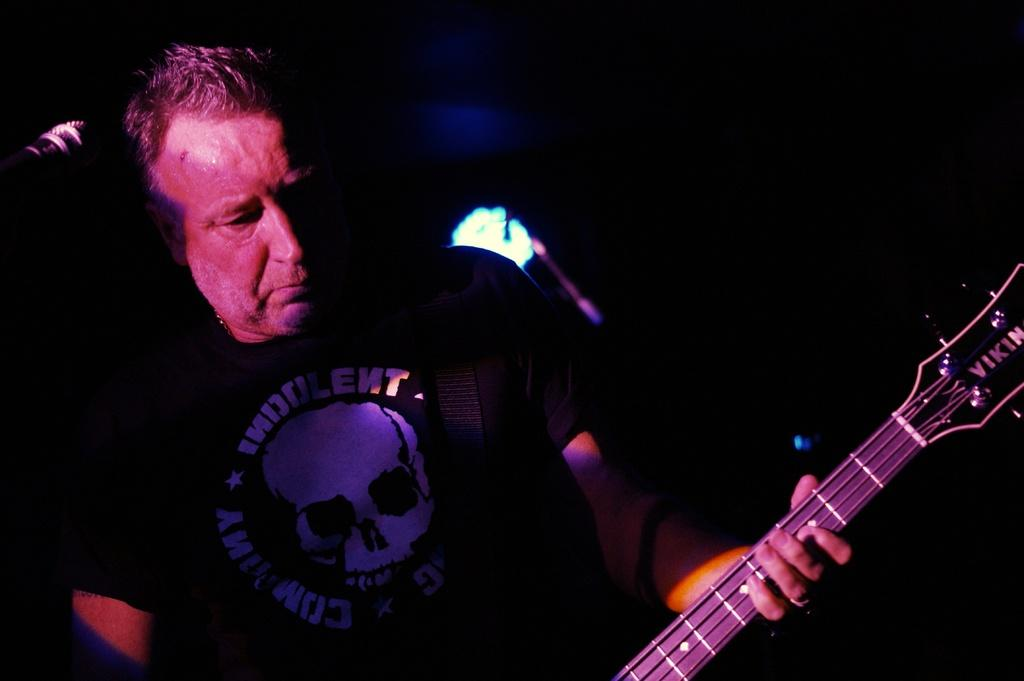Who is present in the image? There is a man in the image. What is the man holding in the image? The man is holding a guitar. What other object can be seen in the image? There is a microphone in the image. How many brothers does the man have in the image? There is no information about the man's brothers in the image. Is there a fire visible in the image? There is no fire present in the image. 